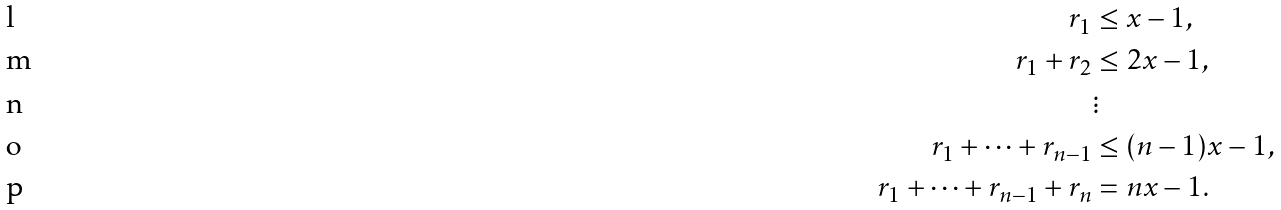<formula> <loc_0><loc_0><loc_500><loc_500>r _ { 1 } & \leq x - 1 , \\ r _ { 1 } + r _ { 2 } & \leq 2 x - 1 , \\ & \vdots \\ r _ { 1 } + \cdots + r _ { n - 1 } & \leq ( n - 1 ) x - 1 , \\ r _ { 1 } + \cdots + r _ { n - 1 } + r _ { n } & = n x - 1 .</formula> 